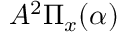<formula> <loc_0><loc_0><loc_500><loc_500>A ^ { 2 } \Pi _ { x } ( \alpha )</formula> 